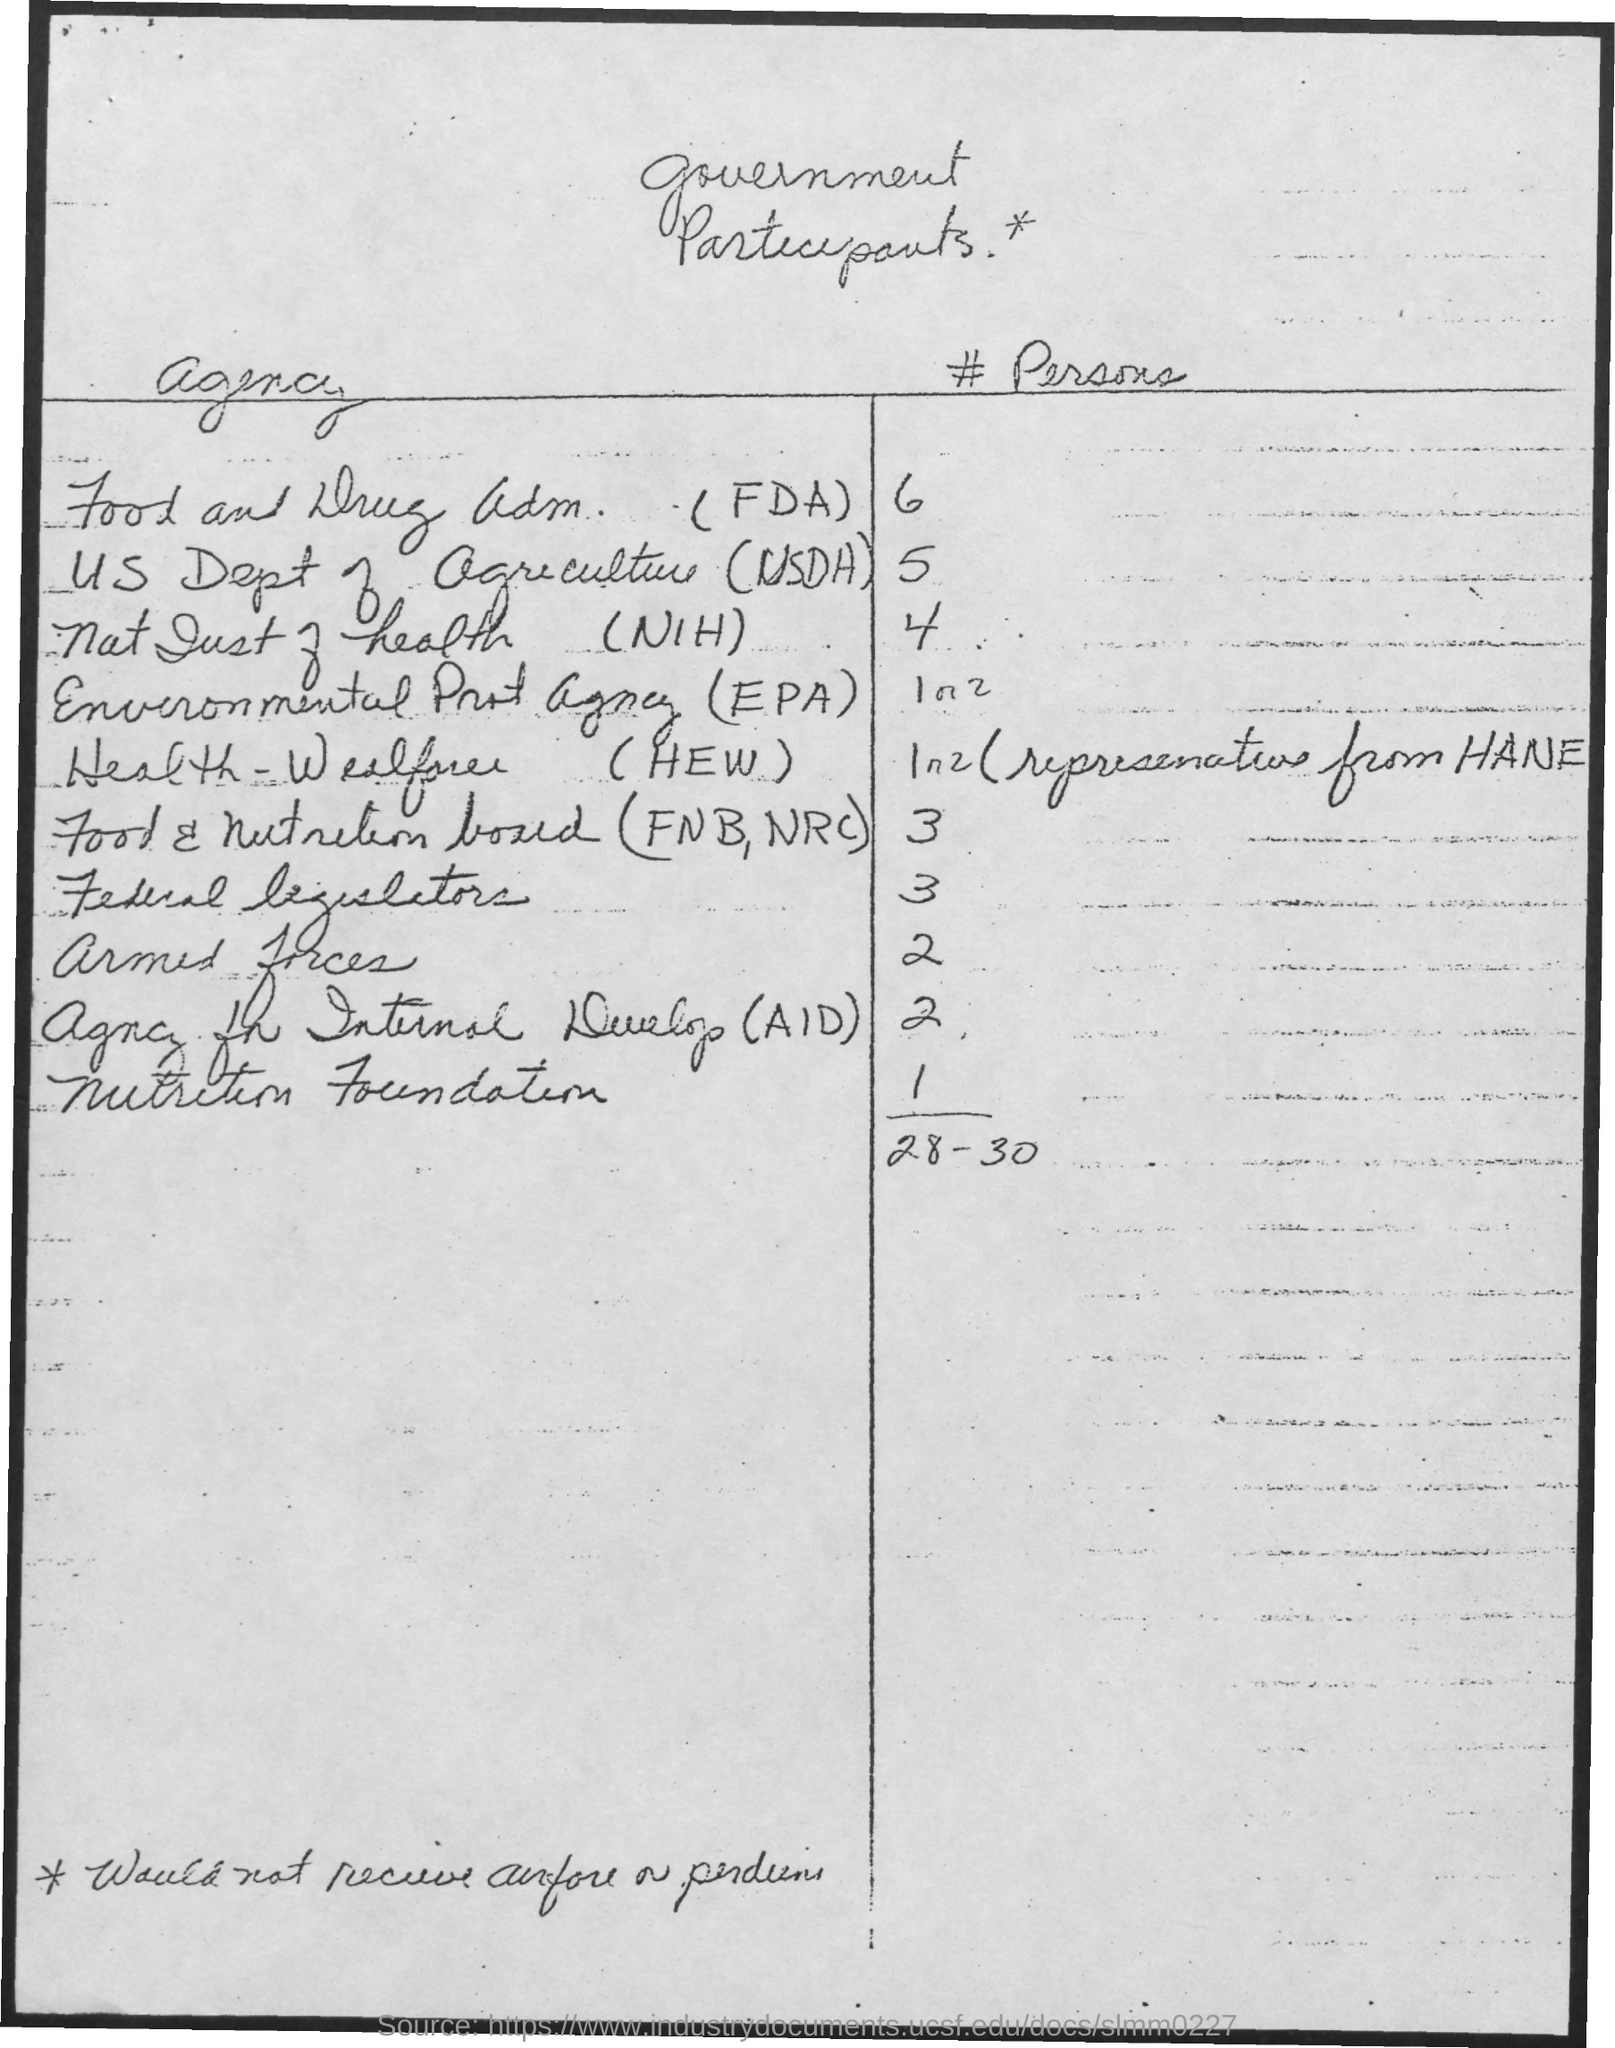What is the heading of the table given at the top of the page?
Keep it short and to the point. Government participants. What heading is given to the first column of the table?
Ensure brevity in your answer.  Agency. What heading is given to the second column of the table?
Your answer should be very brief. # Persons. How many "persons" are participating from "US Dept of agriculture (USDA)"?
Your response must be concise. 5. How many "persons" are participating from "armed forces"?
Your response must be concise. 2. How many "persons" are participating from "nutrition foundation"?
Offer a very short reply. 1. How many "persons" are participating from "nat inst of health (NIH)"?
Provide a short and direct response. 4. How many "persons" are participating from "Food and Drug adm.  (FDA)" ?
Make the answer very short. 6. What is the expansion of "USDA"?
Give a very brief answer. US Dept of Agriculture. 